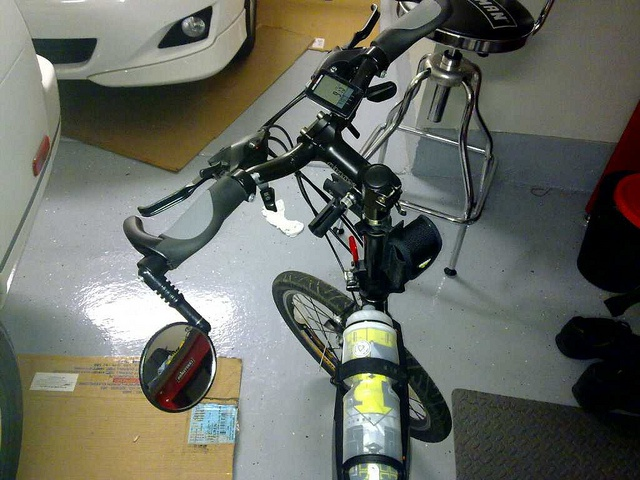Describe the objects in this image and their specific colors. I can see bicycle in darkgray, black, gray, and lightgray tones, chair in darkgray, gray, black, and purple tones, car in darkgray, black, and gray tones, bottle in darkgray, black, lightgray, and gray tones, and car in darkgray, gray, and ivory tones in this image. 